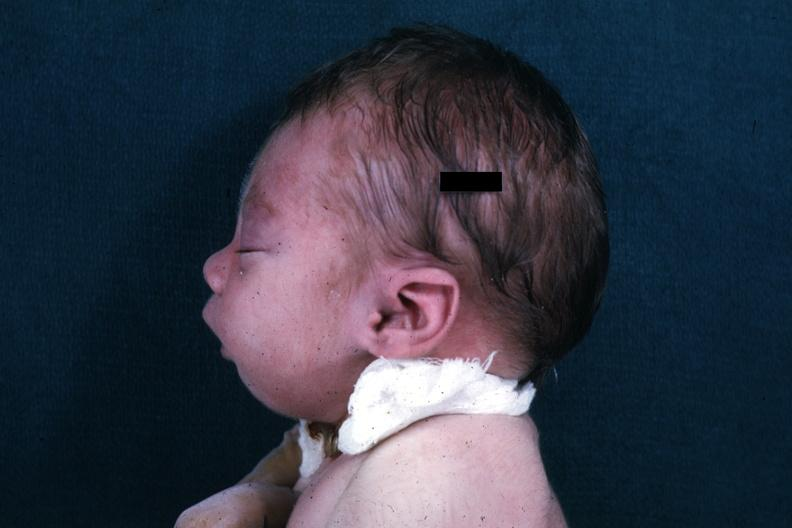does case of peritonitis slide show lateral view of infants head showing mandibular lesion?
Answer the question using a single word or phrase. No 